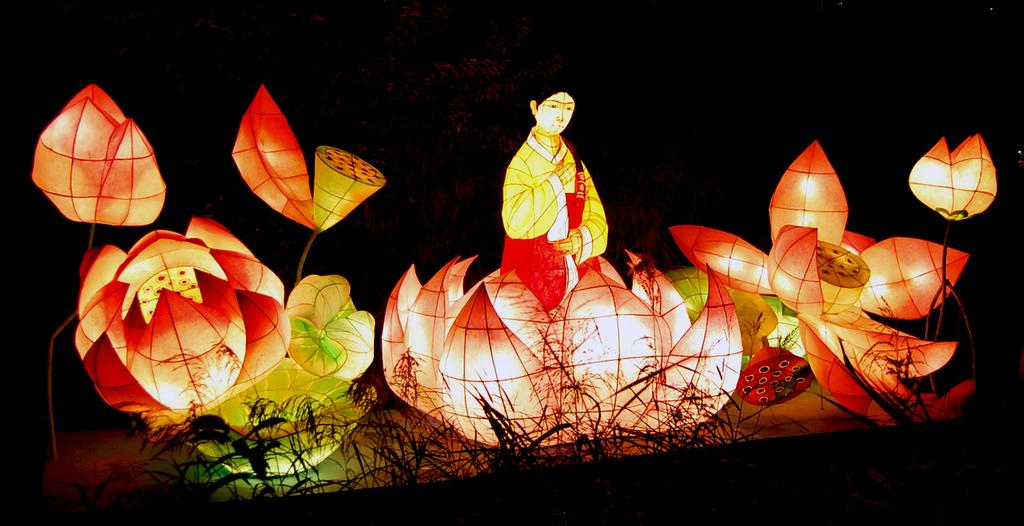What can be observed about the overall appearance of the image? The image contains colorful designs. What is the woman in the image doing? The woman is sitting on a lotus in the image. Are there any additional features on the plastic design? Yes, there are lights on the plastic design in the image. What type of vegetation is visible at the bottom of the image? Plants are visible at the bottom of the image. How many clocks are present on the woman's wrist in the image? There are no clocks visible on the woman's wrist in the image. What type of company is represented by the logo on the woman's shirt in the image? There is no logo or company mentioned or visible in the image. 